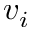Convert formula to latex. <formula><loc_0><loc_0><loc_500><loc_500>v _ { i }</formula> 